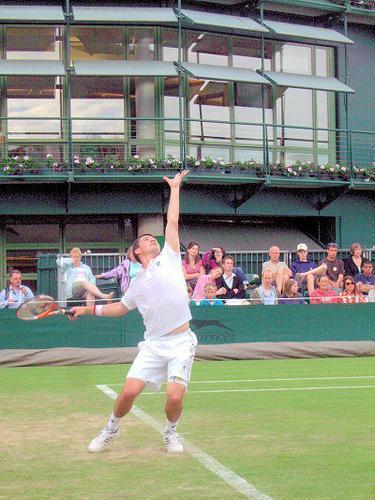How many players do you see?
Give a very brief answer. 1. How many people are in the photo?
Give a very brief answer. 2. 